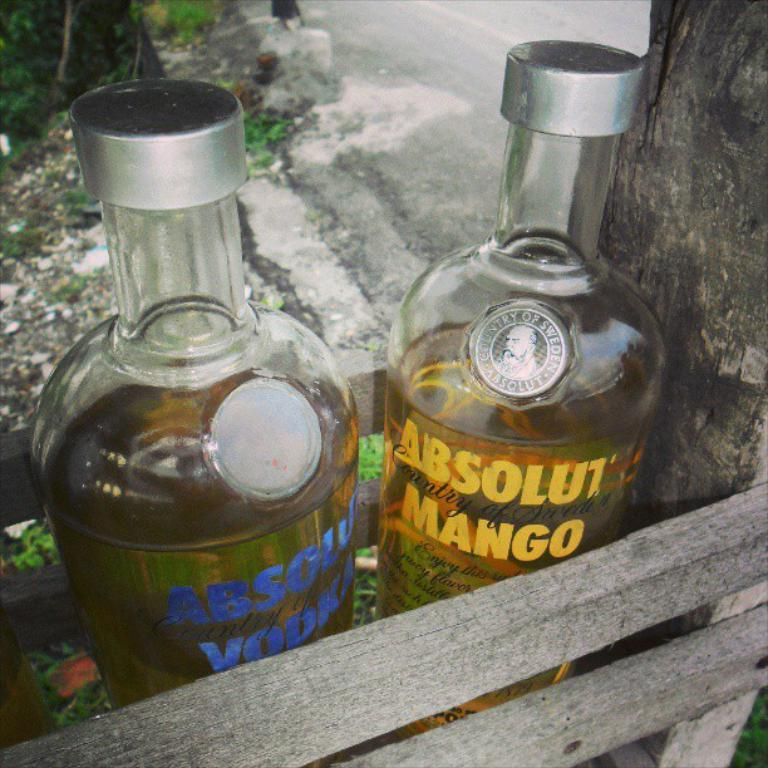<image>
Provide a brief description of the given image. the word absolut is on the front of a bottle 